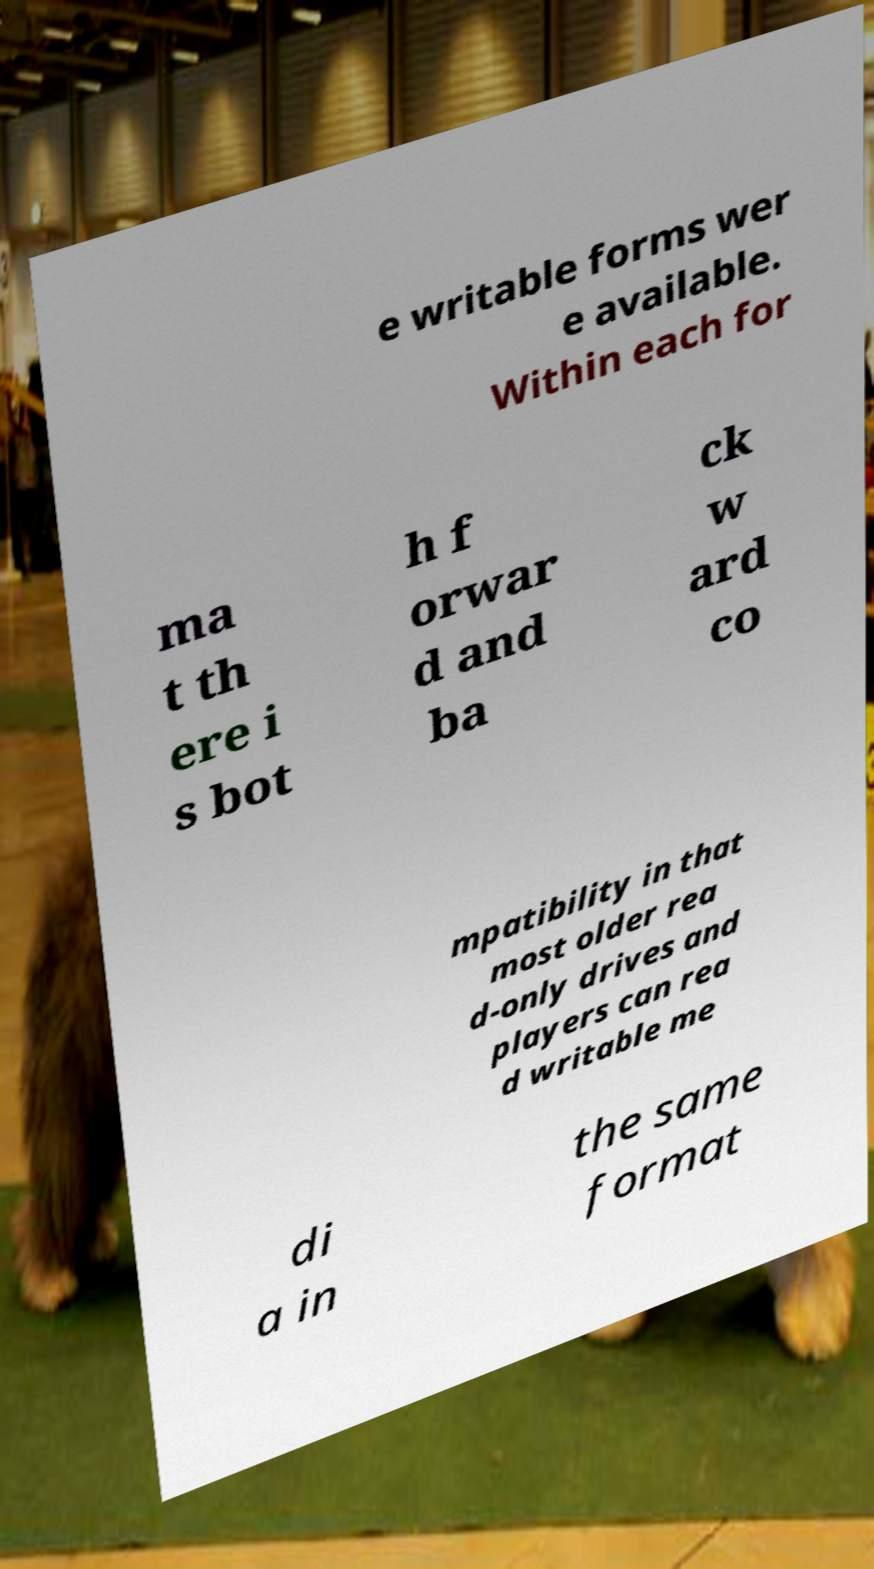For documentation purposes, I need the text within this image transcribed. Could you provide that? e writable forms wer e available. Within each for ma t th ere i s bot h f orwar d and ba ck w ard co mpatibility in that most older rea d-only drives and players can rea d writable me di a in the same format 